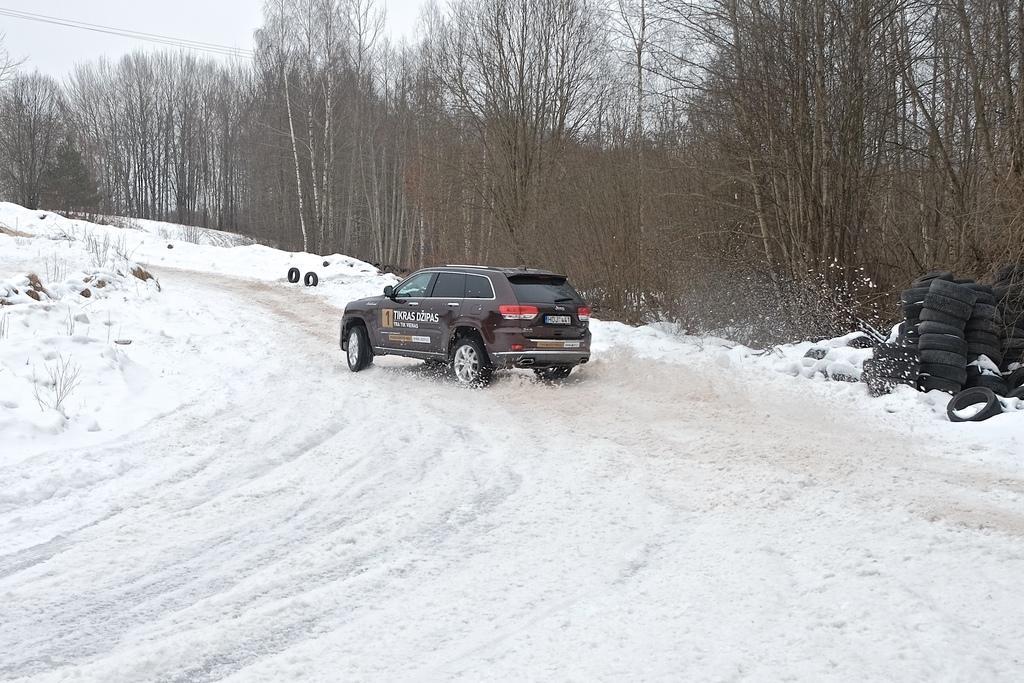In one or two sentences, can you explain what this image depicts? As we can see in the image there is snow, car, tyres, trees and sky. 